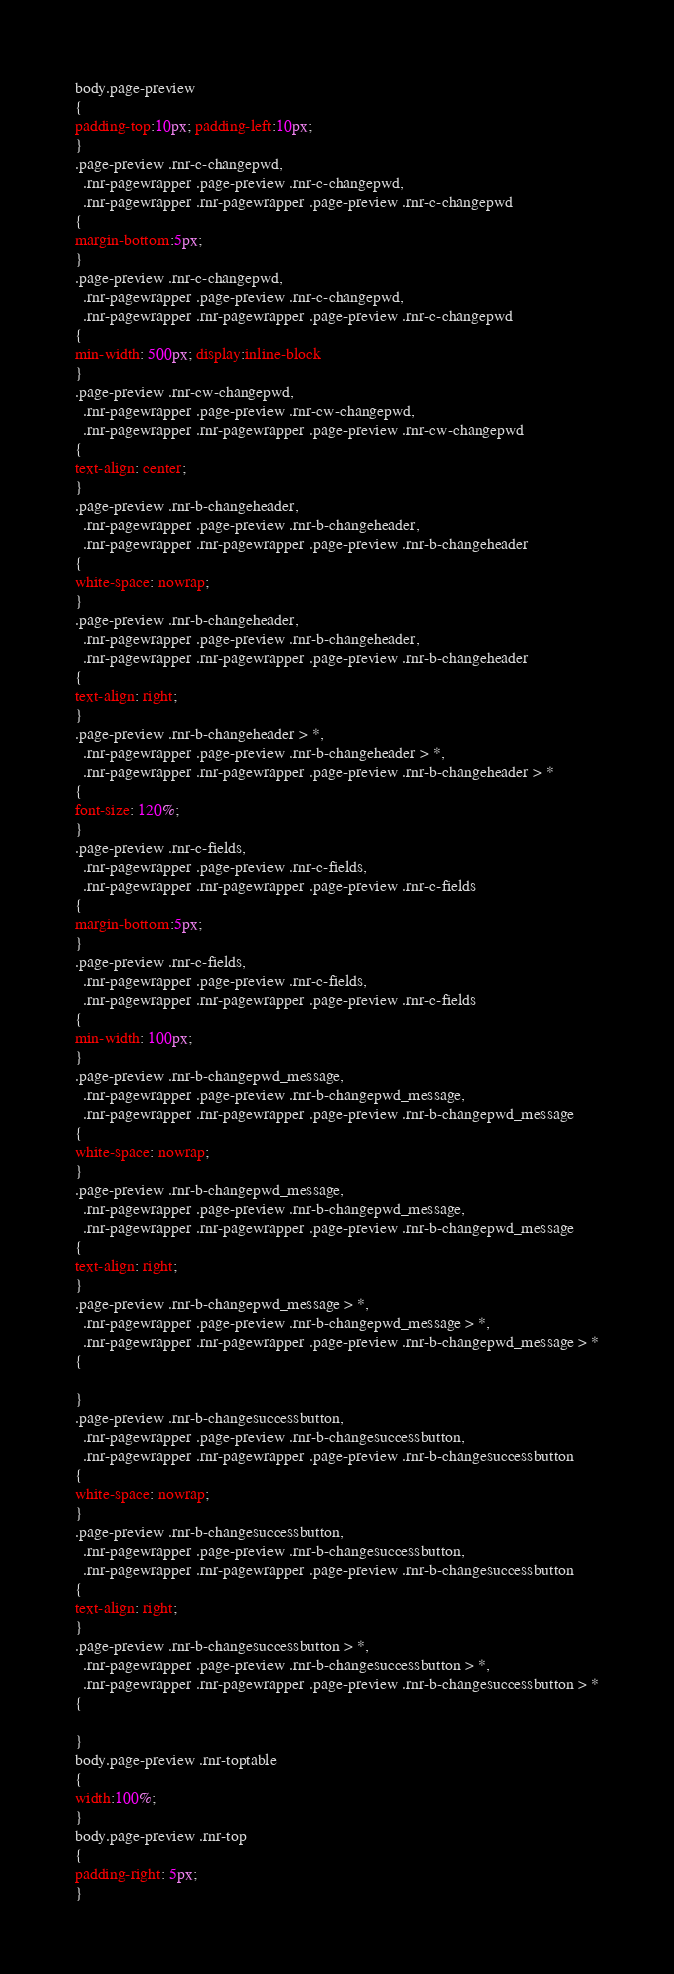<code> <loc_0><loc_0><loc_500><loc_500><_CSS_>body.page-preview
{
padding-top:10px; padding-left:10px;
}
.page-preview .rnr-c-changepwd,
  .rnr-pagewrapper .page-preview .rnr-c-changepwd,
  .rnr-pagewrapper .rnr-pagewrapper .page-preview .rnr-c-changepwd
{
margin-bottom:5px;
}
.page-preview .rnr-c-changepwd,
  .rnr-pagewrapper .page-preview .rnr-c-changepwd,
  .rnr-pagewrapper .rnr-pagewrapper .page-preview .rnr-c-changepwd
{
min-width: 500px; display:inline-block
}
.page-preview .rnr-cw-changepwd,
  .rnr-pagewrapper .page-preview .rnr-cw-changepwd,
  .rnr-pagewrapper .rnr-pagewrapper .page-preview .rnr-cw-changepwd
{
text-align: center;
}
.page-preview .rnr-b-changeheader,
  .rnr-pagewrapper .page-preview .rnr-b-changeheader,
  .rnr-pagewrapper .rnr-pagewrapper .page-preview .rnr-b-changeheader
{
white-space: nowrap;
}
.page-preview .rnr-b-changeheader,
  .rnr-pagewrapper .page-preview .rnr-b-changeheader,
  .rnr-pagewrapper .rnr-pagewrapper .page-preview .rnr-b-changeheader
{
text-align: right;
}
.page-preview .rnr-b-changeheader > *,
  .rnr-pagewrapper .page-preview .rnr-b-changeheader > *,
  .rnr-pagewrapper .rnr-pagewrapper .page-preview .rnr-b-changeheader > *
{
font-size: 120%;
}
.page-preview .rnr-c-fields,
  .rnr-pagewrapper .page-preview .rnr-c-fields,
  .rnr-pagewrapper .rnr-pagewrapper .page-preview .rnr-c-fields
{
margin-bottom:5px;
}
.page-preview .rnr-c-fields,
  .rnr-pagewrapper .page-preview .rnr-c-fields,
  .rnr-pagewrapper .rnr-pagewrapper .page-preview .rnr-c-fields
{
min-width: 100px;
}
.page-preview .rnr-b-changepwd_message,
  .rnr-pagewrapper .page-preview .rnr-b-changepwd_message,
  .rnr-pagewrapper .rnr-pagewrapper .page-preview .rnr-b-changepwd_message
{
white-space: nowrap;
}
.page-preview .rnr-b-changepwd_message,
  .rnr-pagewrapper .page-preview .rnr-b-changepwd_message,
  .rnr-pagewrapper .rnr-pagewrapper .page-preview .rnr-b-changepwd_message
{
text-align: right;
}
.page-preview .rnr-b-changepwd_message > *,
  .rnr-pagewrapper .page-preview .rnr-b-changepwd_message > *,
  .rnr-pagewrapper .rnr-pagewrapper .page-preview .rnr-b-changepwd_message > *
{

}
.page-preview .rnr-b-changesuccessbutton,
  .rnr-pagewrapper .page-preview .rnr-b-changesuccessbutton,
  .rnr-pagewrapper .rnr-pagewrapper .page-preview .rnr-b-changesuccessbutton
{
white-space: nowrap;
}
.page-preview .rnr-b-changesuccessbutton,
  .rnr-pagewrapper .page-preview .rnr-b-changesuccessbutton,
  .rnr-pagewrapper .rnr-pagewrapper .page-preview .rnr-b-changesuccessbutton
{
text-align: right;
}
.page-preview .rnr-b-changesuccessbutton > *,
  .rnr-pagewrapper .page-preview .rnr-b-changesuccessbutton > *,
  .rnr-pagewrapper .rnr-pagewrapper .page-preview .rnr-b-changesuccessbutton > *
{

}
body.page-preview .rnr-toptable
{
width:100%;
}
body.page-preview .rnr-top
{
padding-right: 5px;
}
</code> 